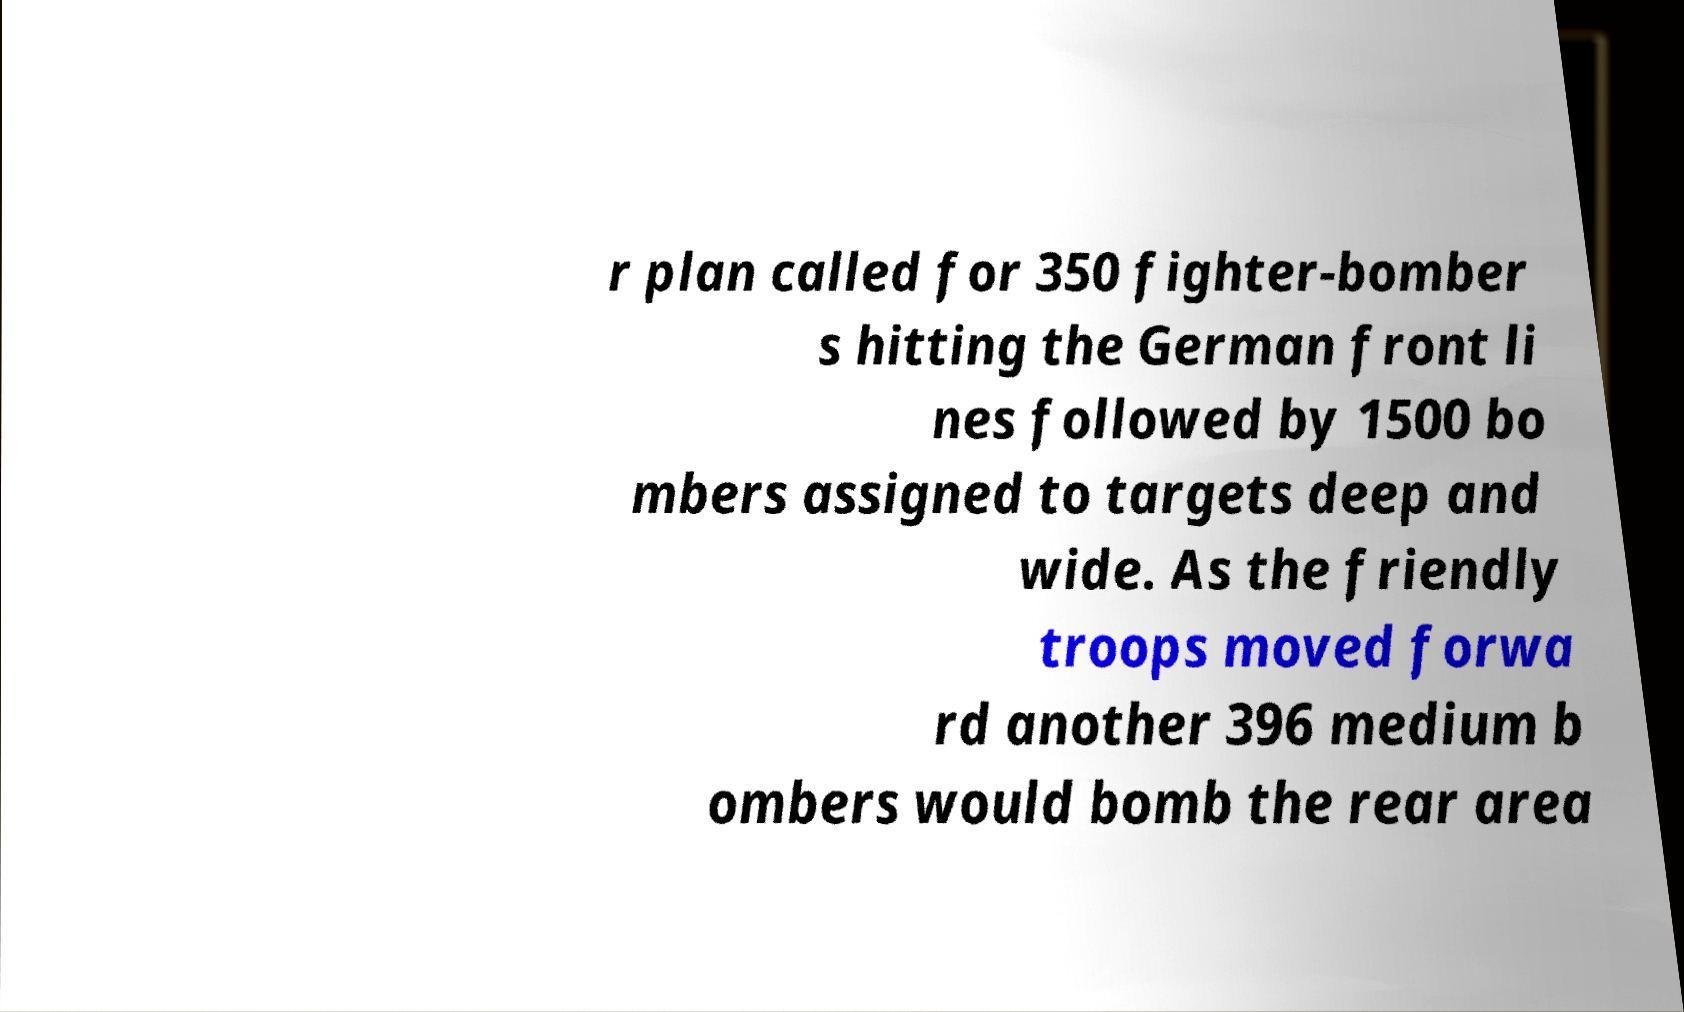For documentation purposes, I need the text within this image transcribed. Could you provide that? r plan called for 350 fighter-bomber s hitting the German front li nes followed by 1500 bo mbers assigned to targets deep and wide. As the friendly troops moved forwa rd another 396 medium b ombers would bomb the rear area 